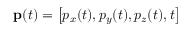<formula> <loc_0><loc_0><loc_500><loc_500>p ( t ) = \left [ p _ { x } ( t ) , p _ { y } ( t ) , p _ { z } ( t ) , t \right ]</formula> 